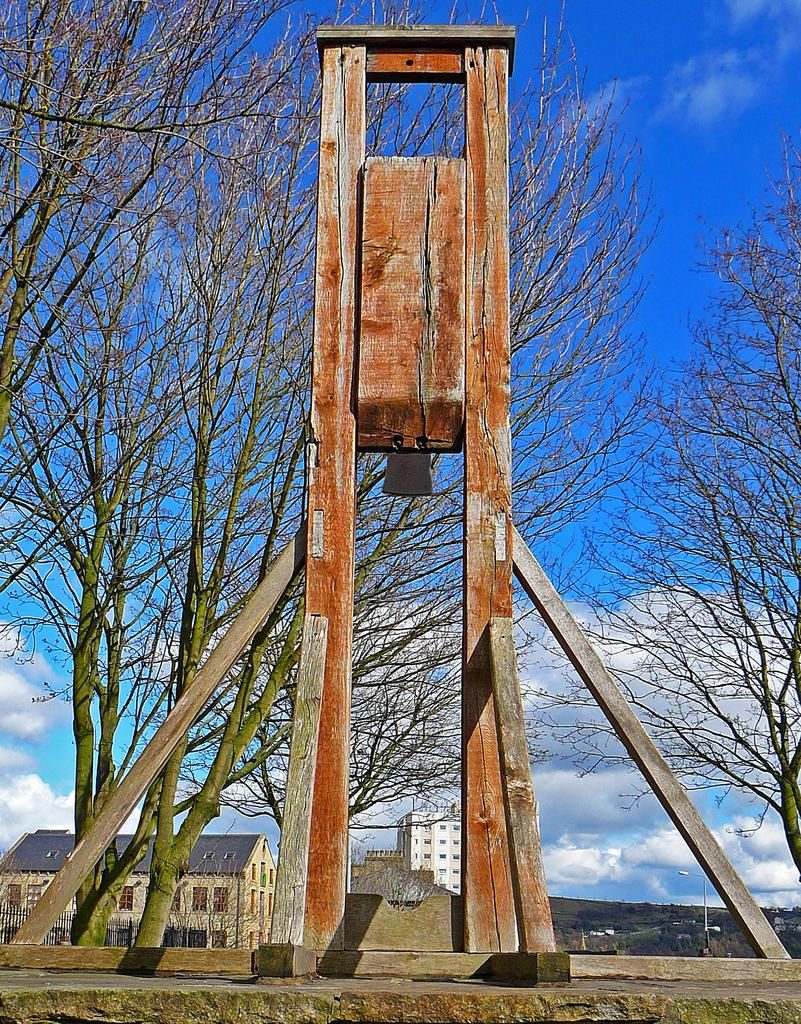What type of objects can be seen in the image? There are wooden poles in the image. Can you describe the appearance of the wooden poles? The wooden poles are brown and ash in color. What can be seen in the background of the image? There are trees, buildings, and the sky visible in the background of the image. How do the wooden poles express hate towards the trees in the image? The wooden poles do not express hate towards the trees in the image, as they are inanimate objects and cannot express emotions. 